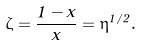Convert formula to latex. <formula><loc_0><loc_0><loc_500><loc_500>\zeta = \frac { 1 - x } { x } = \eta ^ { 1 / 2 } .</formula> 